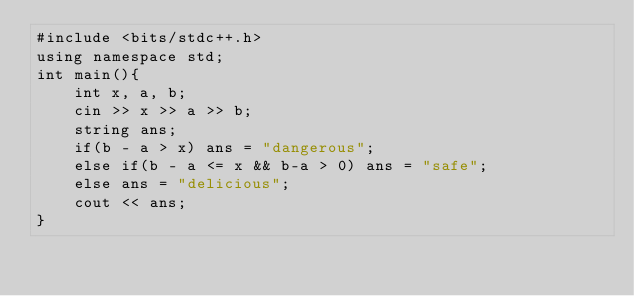<code> <loc_0><loc_0><loc_500><loc_500><_Java_>#include <bits/stdc++.h>
using namespace std;
int main(){
    int x, a, b;
    cin >> x >> a >> b;
    string ans;
    if(b - a > x) ans = "dangerous";
    else if(b - a <= x && b-a > 0) ans = "safe";
    else ans = "delicious";
    cout << ans;
}</code> 